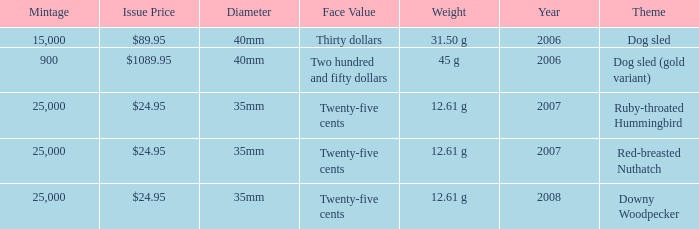What is the MIntage after 2006 of the Ruby-Throated Hummingbird Theme coin? 25000.0. 